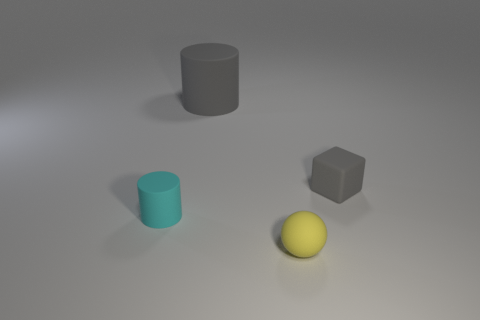Subtract all cyan cylinders. How many cylinders are left? 1 Add 2 small blue matte cylinders. How many objects exist? 6 Subtract 1 cylinders. How many cylinders are left? 1 Subtract all green balls. Subtract all cyan cylinders. How many balls are left? 1 Subtract all green cylinders. How many green blocks are left? 0 Subtract all tiny gray blocks. Subtract all cubes. How many objects are left? 2 Add 4 cyan cylinders. How many cyan cylinders are left? 5 Add 4 yellow rubber things. How many yellow rubber things exist? 5 Subtract 0 red balls. How many objects are left? 4 Subtract all cubes. How many objects are left? 3 